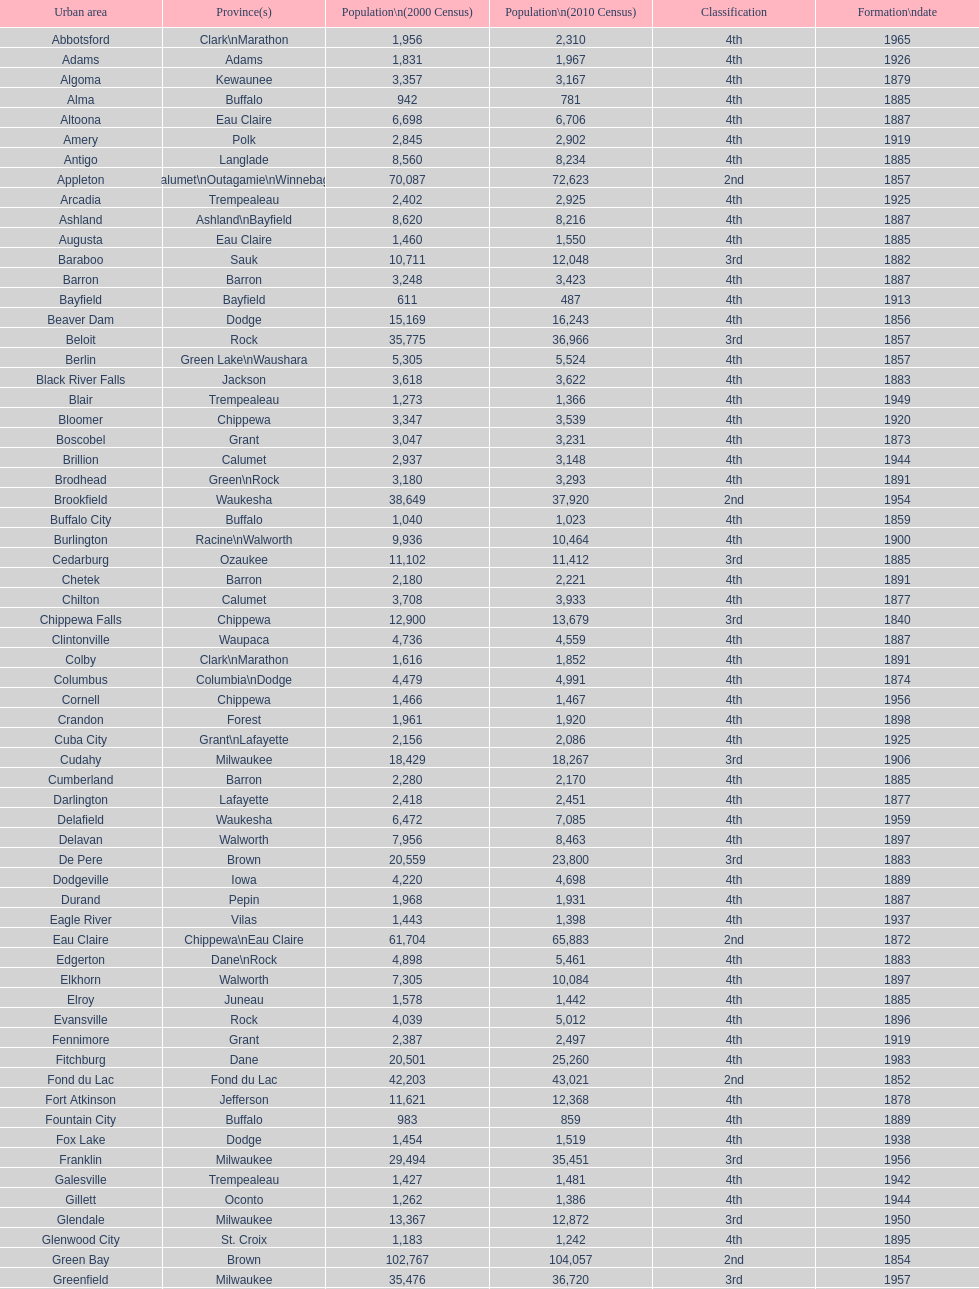Could you help me parse every detail presented in this table? {'header': ['Urban area', 'Province(s)', 'Population\\n(2000 Census)', 'Population\\n(2010 Census)', 'Classification', 'Formation\\ndate'], 'rows': [['Abbotsford', 'Clark\\nMarathon', '1,956', '2,310', '4th', '1965'], ['Adams', 'Adams', '1,831', '1,967', '4th', '1926'], ['Algoma', 'Kewaunee', '3,357', '3,167', '4th', '1879'], ['Alma', 'Buffalo', '942', '781', '4th', '1885'], ['Altoona', 'Eau Claire', '6,698', '6,706', '4th', '1887'], ['Amery', 'Polk', '2,845', '2,902', '4th', '1919'], ['Antigo', 'Langlade', '8,560', '8,234', '4th', '1885'], ['Appleton', 'Calumet\\nOutagamie\\nWinnebago', '70,087', '72,623', '2nd', '1857'], ['Arcadia', 'Trempealeau', '2,402', '2,925', '4th', '1925'], ['Ashland', 'Ashland\\nBayfield', '8,620', '8,216', '4th', '1887'], ['Augusta', 'Eau Claire', '1,460', '1,550', '4th', '1885'], ['Baraboo', 'Sauk', '10,711', '12,048', '3rd', '1882'], ['Barron', 'Barron', '3,248', '3,423', '4th', '1887'], ['Bayfield', 'Bayfield', '611', '487', '4th', '1913'], ['Beaver Dam', 'Dodge', '15,169', '16,243', '4th', '1856'], ['Beloit', 'Rock', '35,775', '36,966', '3rd', '1857'], ['Berlin', 'Green Lake\\nWaushara', '5,305', '5,524', '4th', '1857'], ['Black River Falls', 'Jackson', '3,618', '3,622', '4th', '1883'], ['Blair', 'Trempealeau', '1,273', '1,366', '4th', '1949'], ['Bloomer', 'Chippewa', '3,347', '3,539', '4th', '1920'], ['Boscobel', 'Grant', '3,047', '3,231', '4th', '1873'], ['Brillion', 'Calumet', '2,937', '3,148', '4th', '1944'], ['Brodhead', 'Green\\nRock', '3,180', '3,293', '4th', '1891'], ['Brookfield', 'Waukesha', '38,649', '37,920', '2nd', '1954'], ['Buffalo City', 'Buffalo', '1,040', '1,023', '4th', '1859'], ['Burlington', 'Racine\\nWalworth', '9,936', '10,464', '4th', '1900'], ['Cedarburg', 'Ozaukee', '11,102', '11,412', '3rd', '1885'], ['Chetek', 'Barron', '2,180', '2,221', '4th', '1891'], ['Chilton', 'Calumet', '3,708', '3,933', '4th', '1877'], ['Chippewa Falls', 'Chippewa', '12,900', '13,679', '3rd', '1840'], ['Clintonville', 'Waupaca', '4,736', '4,559', '4th', '1887'], ['Colby', 'Clark\\nMarathon', '1,616', '1,852', '4th', '1891'], ['Columbus', 'Columbia\\nDodge', '4,479', '4,991', '4th', '1874'], ['Cornell', 'Chippewa', '1,466', '1,467', '4th', '1956'], ['Crandon', 'Forest', '1,961', '1,920', '4th', '1898'], ['Cuba City', 'Grant\\nLafayette', '2,156', '2,086', '4th', '1925'], ['Cudahy', 'Milwaukee', '18,429', '18,267', '3rd', '1906'], ['Cumberland', 'Barron', '2,280', '2,170', '4th', '1885'], ['Darlington', 'Lafayette', '2,418', '2,451', '4th', '1877'], ['Delafield', 'Waukesha', '6,472', '7,085', '4th', '1959'], ['Delavan', 'Walworth', '7,956', '8,463', '4th', '1897'], ['De Pere', 'Brown', '20,559', '23,800', '3rd', '1883'], ['Dodgeville', 'Iowa', '4,220', '4,698', '4th', '1889'], ['Durand', 'Pepin', '1,968', '1,931', '4th', '1887'], ['Eagle River', 'Vilas', '1,443', '1,398', '4th', '1937'], ['Eau Claire', 'Chippewa\\nEau Claire', '61,704', '65,883', '2nd', '1872'], ['Edgerton', 'Dane\\nRock', '4,898', '5,461', '4th', '1883'], ['Elkhorn', 'Walworth', '7,305', '10,084', '4th', '1897'], ['Elroy', 'Juneau', '1,578', '1,442', '4th', '1885'], ['Evansville', 'Rock', '4,039', '5,012', '4th', '1896'], ['Fennimore', 'Grant', '2,387', '2,497', '4th', '1919'], ['Fitchburg', 'Dane', '20,501', '25,260', '4th', '1983'], ['Fond du Lac', 'Fond du Lac', '42,203', '43,021', '2nd', '1852'], ['Fort Atkinson', 'Jefferson', '11,621', '12,368', '4th', '1878'], ['Fountain City', 'Buffalo', '983', '859', '4th', '1889'], ['Fox Lake', 'Dodge', '1,454', '1,519', '4th', '1938'], ['Franklin', 'Milwaukee', '29,494', '35,451', '3rd', '1956'], ['Galesville', 'Trempealeau', '1,427', '1,481', '4th', '1942'], ['Gillett', 'Oconto', '1,262', '1,386', '4th', '1944'], ['Glendale', 'Milwaukee', '13,367', '12,872', '3rd', '1950'], ['Glenwood City', 'St. Croix', '1,183', '1,242', '4th', '1895'], ['Green Bay', 'Brown', '102,767', '104,057', '2nd', '1854'], ['Greenfield', 'Milwaukee', '35,476', '36,720', '3rd', '1957'], ['Green Lake', 'Green Lake', '1,100', '960', '4th', '1962'], ['Greenwood', 'Clark', '1,079', '1,026', '4th', '1891'], ['Hartford', 'Dodge\\nWashington', '10,905', '14,223', '3rd', '1883'], ['Hayward', 'Sawyer', '2,129', '2,318', '4th', '1915'], ['Hillsboro', 'Vernon', '1,302', '1,417', '4th', '1885'], ['Horicon', 'Dodge', '3,775', '3,655', '4th', '1897'], ['Hudson', 'St. Croix', '8,775', '12,719', '4th', '1858'], ['Hurley', 'Iron', '1,818', '1,547', '4th', '1918'], ['Independence', 'Trempealeau', '1,244', '1,336', '4th', '1942'], ['Janesville', 'Rock', '59,498', '63,575', '2nd', '1853'], ['Jefferson', 'Jefferson', '7,338', '7,973', '4th', '1878'], ['Juneau', 'Dodge', '2,485', '2,814', '4th', '1887'], ['Kaukauna', 'Outagamie', '12,983', '15,462', '3rd', '1885'], ['Kenosha', 'Kenosha', '90,352', '99,218', '2nd', '1850'], ['Kewaunee', 'Kewaunee', '2,806', '2,952', '4th', '1883'], ['Kiel', 'Calumet\\nManitowoc', '3,450', '3,738', '4th', '1920'], ['La Crosse', 'La Crosse', '51,818', '51,320', '2nd', '1856'], ['Ladysmith', 'Rusk', '3,932', '3,414', '4th', '1905'], ['Lake Geneva', 'Walworth', '7,148', '7,651', '4th', '1883'], ['Lake Mills', 'Jefferson', '4,843', '5,708', '4th', '1905'], ['Lancaster', 'Grant', '4,070', '3,868', '4th', '1878'], ['Lodi', 'Columbia', '2,882', '3,050', '4th', '1941'], ['Loyal', 'Clark', '1,308', '1,261', '4th', '1948'], ['Madison', 'Dane', '208,054', '233,209', '2nd', '1856'], ['Manawa', 'Waupaca', '1,330', '1,371', '4th', '1954'], ['Manitowoc', 'Manitowoc', '34,053', '33,736', '3rd', '1870'], ['Marinette', 'Marinette', '11,749', '10,968', '3rd', '1887'], ['Marion', 'Shawano\\nWaupaca', '1,297', '1,260', '4th', '1898'], ['Markesan', 'Green Lake', '1,396', '1,476', '4th', '1959'], ['Marshfield', 'Marathon\\nWood', '18,800', '19,118', '3rd', '1883'], ['Mauston', 'Juneau', '3,740', '4,423', '4th', '1883'], ['Mayville', 'Dodge', '4,902', '5,154', '4th', '1885'], ['Medford', 'Taylor', '4,350', '4,326', '4th', '1889'], ['Mellen', 'Ashland', '845', '731', '4th', '1907'], ['Menasha', 'Calumet\\nWinnebago', '16,331', '17,353', '3rd', '1874'], ['Menomonie', 'Dunn', '14,937', '16,264', '4th', '1882'], ['Mequon', 'Ozaukee', '22,643', '23,132', '4th', '1957'], ['Merrill', 'Lincoln', '10,146', '9,661', '4th', '1883'], ['Middleton', 'Dane', '15,770', '17,442', '3rd', '1963'], ['Milton', 'Rock', '5,132', '5,546', '4th', '1969'], ['Milwaukee', 'Milwaukee\\nWashington\\nWaukesha', '596,974', '594,833', '1st', '1846'], ['Mineral Point', 'Iowa', '2,617', '2,487', '4th', '1857'], ['Mondovi', 'Buffalo', '2,634', '2,777', '4th', '1889'], ['Monona', 'Dane', '8,018', '7,533', '4th', '1969'], ['Monroe', 'Green', '10,843', '10,827', '4th', '1882'], ['Montello', 'Marquette', '1,397', '1,495', '4th', '1938'], ['Montreal', 'Iron', '838', '807', '4th', '1924'], ['Mosinee', 'Marathon', '4,063', '3,988', '4th', '1931'], ['Muskego', 'Waukesha', '21,397', '24,135', '3rd', '1964'], ['Neenah', 'Winnebago', '24,507', '25,501', '3rd', '1873'], ['Neillsville', 'Clark', '2,731', '2,463', '4th', '1882'], ['Nekoosa', 'Wood', '2,590', '2,580', '4th', '1926'], ['New Berlin', 'Waukesha', '38,220', '39,584', '3rd', '1959'], ['New Holstein', 'Calumet', '3,301', '3,236', '4th', '1889'], ['New Lisbon', 'Juneau', '1,436', '2,554', '4th', '1889'], ['New London', 'Outagamie\\nWaupaca', '7,085', '7,295', '4th', '1877'], ['New Richmond', 'St. Croix', '6,310', '8,375', '4th', '1885'], ['Niagara', 'Marinette', '1,880', '1,624', '4th', '1992'], ['Oak Creek', 'Milwaukee', '28,456', '34,451', '3rd', '1955'], ['Oconomowoc', 'Waukesha', '12,382', '15,712', '3rd', '1875'], ['Oconto', 'Oconto', '4,708', '4,513', '4th', '1869'], ['Oconto Falls', 'Oconto', '2,843', '2,891', '4th', '1919'], ['Omro', 'Winnebago', '3,177', '3,517', '4th', '1944'], ['Onalaska', 'La Crosse', '14,839', '17,736', '4th', '1887'], ['Oshkosh', 'Winnebago', '62,916', '66,083', '2nd', '1853'], ['Osseo', 'Trempealeau', '1,669', '1,701', '4th', '1941'], ['Owen', 'Clark', '936', '940', '4th', '1925'], ['Park Falls', 'Price', '2,739', '2,462', '4th', '1912'], ['Peshtigo', 'Marinette', '3,474', '3,502', '4th', '1903'], ['Pewaukee', 'Waukesha', '11,783', '13,195', '3rd', '1999'], ['Phillips', 'Price', '1,675', '1,478', '4th', '1891'], ['Pittsville', 'Wood', '866', '874', '4th', '1887'], ['Platteville', 'Grant', '9,989', '11,224', '4th', '1876'], ['Plymouth', 'Sheboygan', '7,781', '8,445', '4th', '1877'], ['Port Washington', 'Ozaukee', '10,467', '11,250', '4th', '1882'], ['Portage', 'Columbia', '9,728', '10,324', '4th', '1854'], ['Prairie du Chien', 'Crawford', '6,018', '5,911', '4th', '1872'], ['Prescott', 'Pierce', '3,764', '4,258', '4th', '1857'], ['Princeton', 'Green Lake', '1,504', '1,214', '4th', '1920'], ['Racine', 'Racine', '81,855', '78,860', '2nd', '1848'], ['Reedsburg', 'Sauk', '7,827', '10,014', '4th', '1887'], ['Rhinelander', 'Oneida', '7,735', '7,798', '4th', '1894'], ['Rice Lake', 'Barron', '8,312', '8,438', '4th', '1887'], ['Richland Center', 'Richland', '5,114', '5,184', '4th', '1887'], ['Ripon', 'Fond du Lac', '7,450', '7,733', '4th', '1858'], ['River Falls', 'Pierce\\nSt. Croix', '12,560', '15,000', '3rd', '1875'], ['St. Croix Falls', 'Polk', '2,033', '2,133', '4th', '1958'], ['St. Francis', 'Milwaukee', '8,662', '9,365', '4th', '1951'], ['Schofield', 'Marathon', '2,117', '2,169', '4th', '1951'], ['Seymour', 'Outagamie', '3,335', '3,451', '4th', '1879'], ['Shawano', 'Shawano', '8,298', '9,305', '4th', '1874'], ['Sheboygan', 'Sheboygan', '50,792', '49,288', '2nd', '1853'], ['Sheboygan Falls', 'Sheboygan', '6,772', '7,775', '4th', '1913'], ['Shell Lake', 'Washburn', '1,309', '1,347', '4th', '1961'], ['Shullsburg', 'Lafayette', '1,246', '1,226', '4th', '1889'], ['South Milwaukee', 'Milwaukee', '21,256', '21,156', '4th', '1897'], ['Sparta', 'Monroe', '8,648', '9,522', '4th', '1883'], ['Spooner', 'Washburn', '2,653', '2,682', '4th', '1909'], ['Stanley', 'Chippewa\\nClark', '1,898', '3,608', '4th', '1898'], ['Stevens Point', 'Portage', '24,551', '26,717', '3rd', '1858'], ['Stoughton', 'Dane', '12,354', '12,611', '4th', '1882'], ['Sturgeon Bay', 'Door', '9,437', '9,144', '4th', '1883'], ['Sun Prairie', 'Dane', '20,369', '29,364', '3rd', '1958'], ['Superior', 'Douglas', '27,368', '27,244', '2nd', '1858'], ['Thorp', 'Clark', '1,536', '1,621', '4th', '1948'], ['Tomah', 'Monroe', '8,419', '9,093', '4th', '1883'], ['Tomahawk', 'Lincoln', '3,770', '3,397', '4th', '1891'], ['Two Rivers', 'Manitowoc', '12,639', '11,712', '3rd', '1878'], ['Verona', 'Dane', '7,052', '10,619', '4th', '1977'], ['Viroqua', 'Vernon', '4,335', '5,079', '4th', '1885'], ['Washburn', 'Bayfield', '2,280', '2,117', '4th', '1904'], ['Waterloo', 'Jefferson', '3,259', '3,333', '4th', '1962'], ['Watertown', 'Dodge\\nJefferson', '21,598', '23,861', '3rd', '1853'], ['Waukesha', 'Waukesha', '64,825', '70,718', '2nd', '1895'], ['Waupaca', 'Waupaca', '5,676', '6,069', '4th', '1878'], ['Waupun', 'Dodge\\nFond du Lac', '10,944', '11,340', '4th', '1878'], ['Wausau', 'Marathon', '38,426', '39,106', '3rd', '1872'], ['Wautoma', 'Waushara', '1,998', '2,218', '4th', '1901'], ['Wauwatosa', 'Milwaukee', '47,271', '46,396', '2nd', '1897'], ['West Allis', 'Milwaukee', '61,254', '60,411', '2nd', '1906'], ['West Bend', 'Washington', '28,152', '31,078', '3rd', '1885'], ['Westby', 'Vernon', '2,045', '2,200', '4th', '1920'], ['Weyauwega', 'Waupaca', '1,806', '1,900', '4th', '1939'], ['Whitehall', 'Trempealeau', '1,651', '1,558', '4th', '1941'], ['Whitewater', 'Jefferson\\nWalworth', '13,437', '14,390', '4th', '1885'], ['Wisconsin Dells', 'Adams\\nColumbia\\nJuneau\\nSauk', '2,418', '2,678', '4th', '1925'], ['Wisconsin Rapids', 'Wood', '18,435', '18,367', '3rd', '1869']]} How many cities are in wisconsin? 190. 